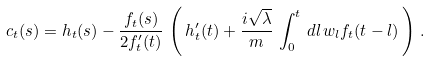Convert formula to latex. <formula><loc_0><loc_0><loc_500><loc_500>c _ { t } ( s ) = h _ { t } ( s ) - \frac { f _ { t } ( s ) } { 2 f ^ { \prime } _ { t } ( t ) } \, \left ( \, h ^ { \prime } _ { t } ( t ) + \frac { i \sqrt { \lambda } } { m } \, \int _ { 0 } ^ { t } \, d l \, w _ { l } f _ { t } ( t - l ) \, \right ) \, .</formula> 